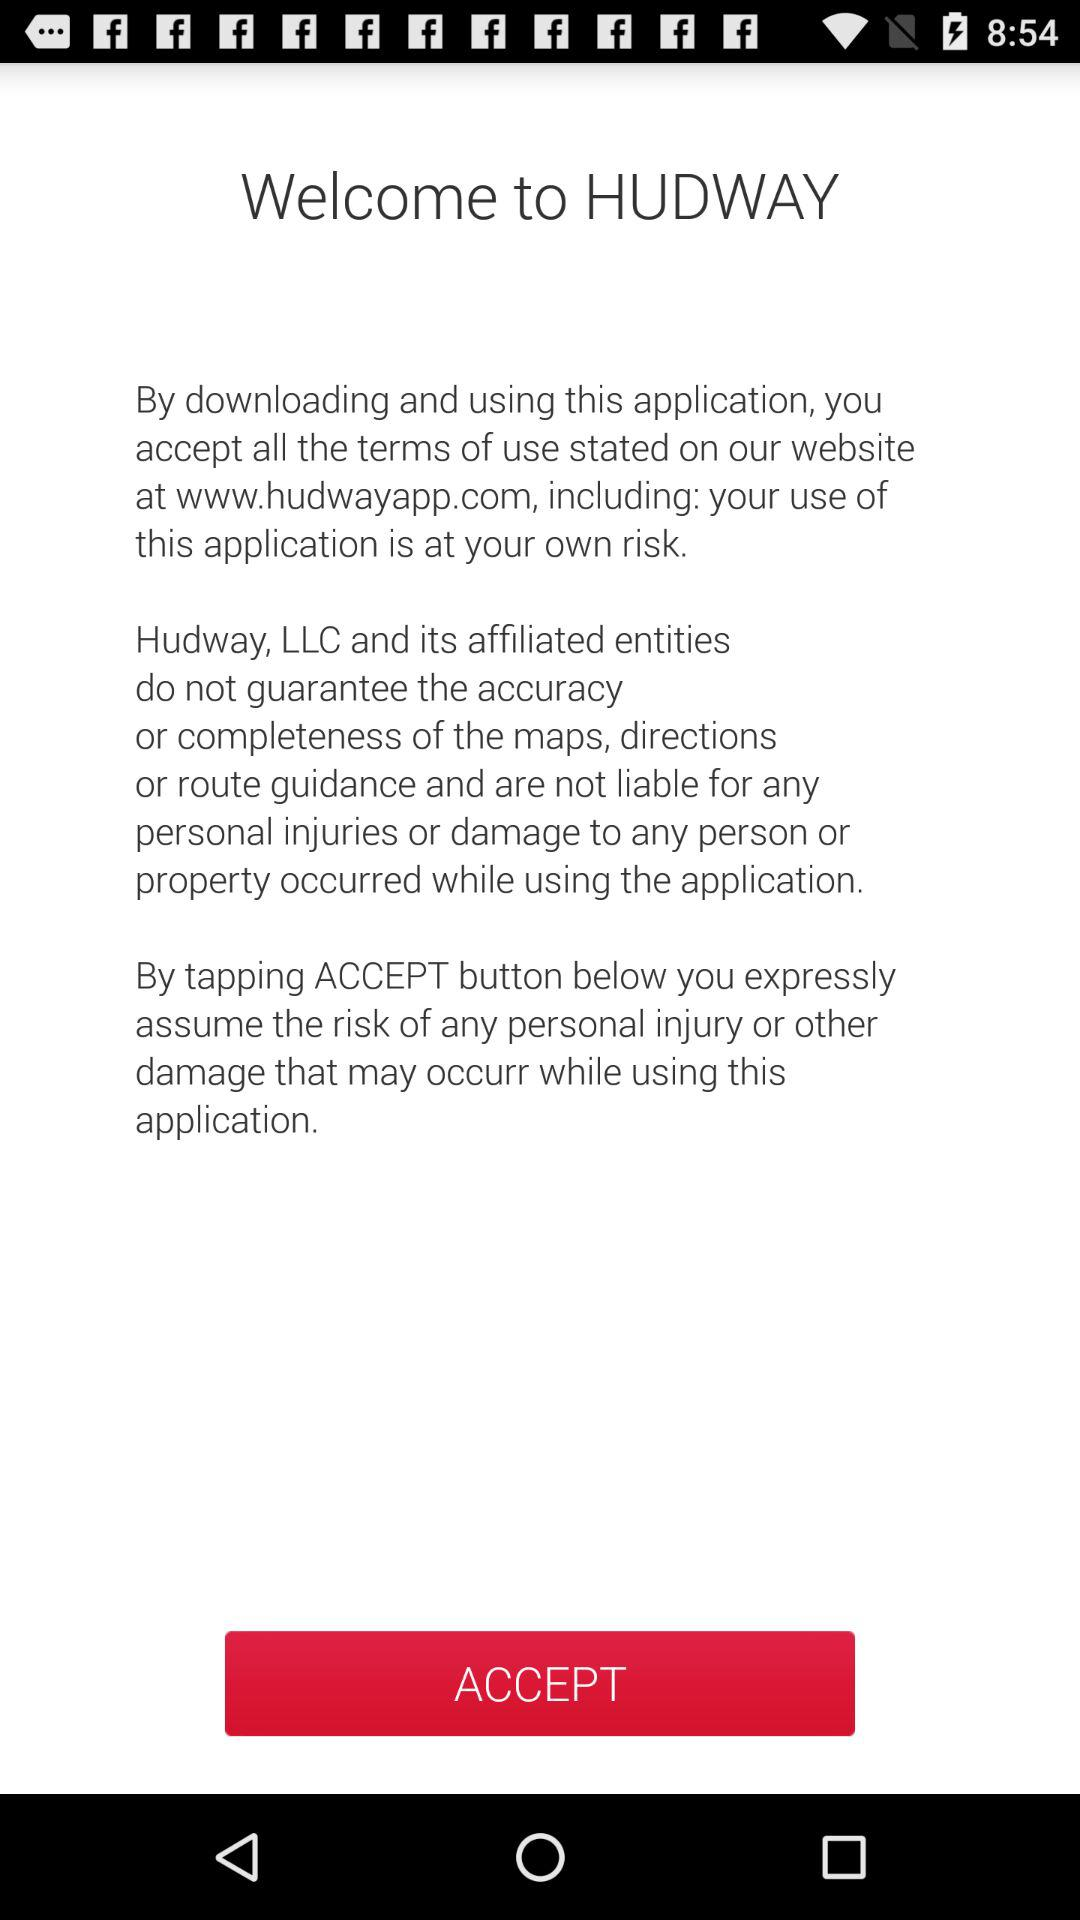What is the application name? The application name is "HUDWAY". 